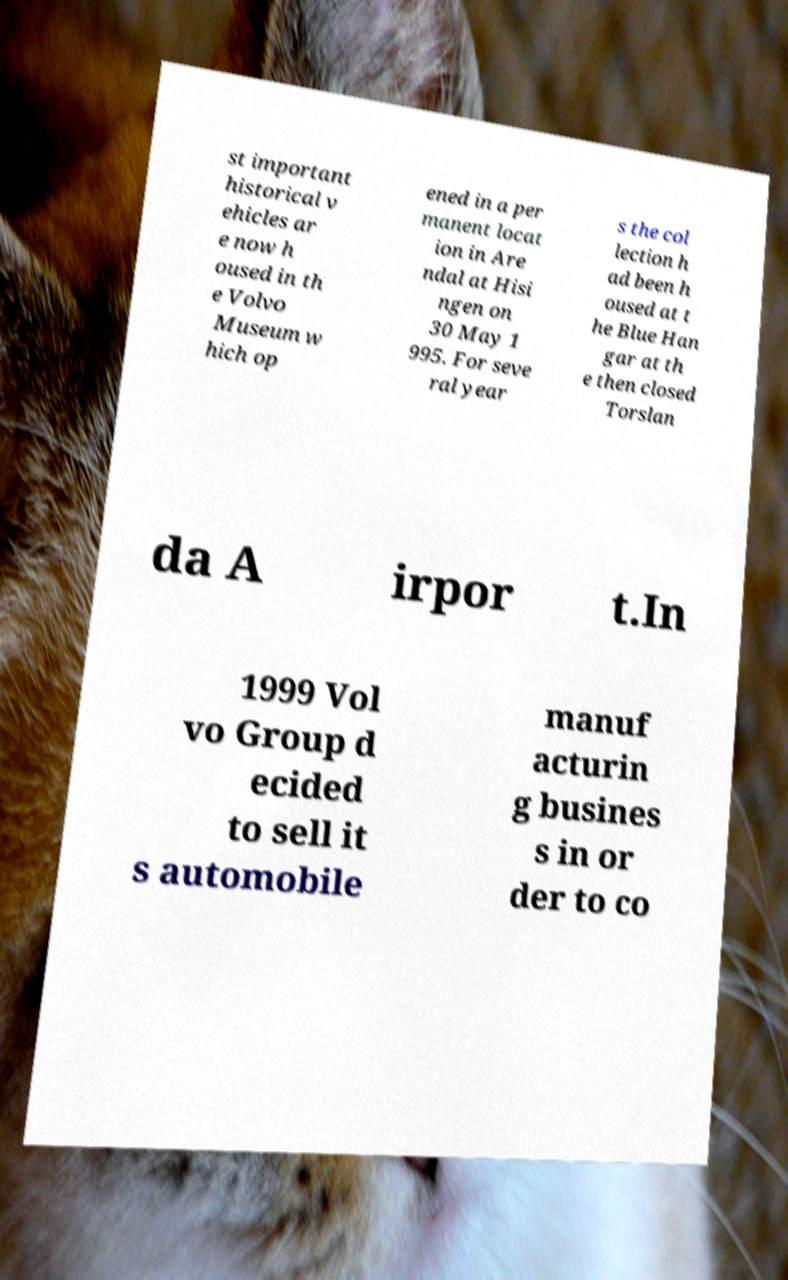Can you read and provide the text displayed in the image?This photo seems to have some interesting text. Can you extract and type it out for me? st important historical v ehicles ar e now h oused in th e Volvo Museum w hich op ened in a per manent locat ion in Are ndal at Hisi ngen on 30 May 1 995. For seve ral year s the col lection h ad been h oused at t he Blue Han gar at th e then closed Torslan da A irpor t.In 1999 Vol vo Group d ecided to sell it s automobile manuf acturin g busines s in or der to co 